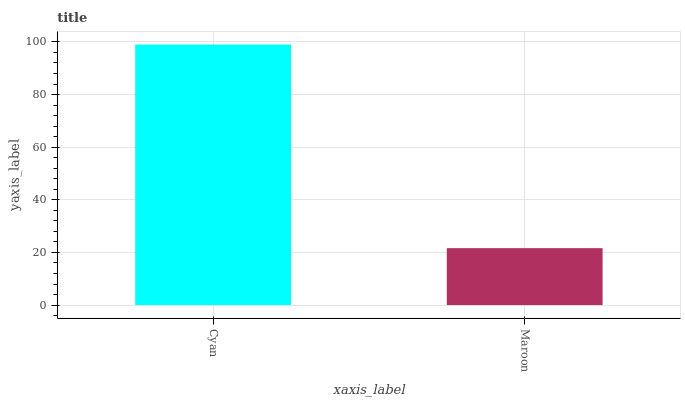Is Maroon the minimum?
Answer yes or no. Yes. Is Cyan the maximum?
Answer yes or no. Yes. Is Maroon the maximum?
Answer yes or no. No. Is Cyan greater than Maroon?
Answer yes or no. Yes. Is Maroon less than Cyan?
Answer yes or no. Yes. Is Maroon greater than Cyan?
Answer yes or no. No. Is Cyan less than Maroon?
Answer yes or no. No. Is Cyan the high median?
Answer yes or no. Yes. Is Maroon the low median?
Answer yes or no. Yes. Is Maroon the high median?
Answer yes or no. No. Is Cyan the low median?
Answer yes or no. No. 